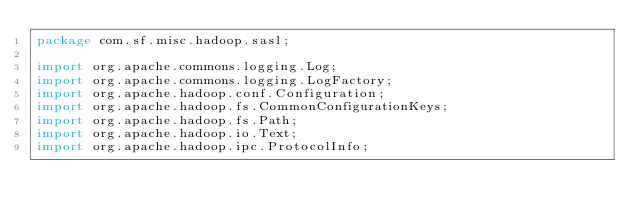<code> <loc_0><loc_0><loc_500><loc_500><_Java_>package com.sf.misc.hadoop.sasl;

import org.apache.commons.logging.Log;
import org.apache.commons.logging.LogFactory;
import org.apache.hadoop.conf.Configuration;
import org.apache.hadoop.fs.CommonConfigurationKeys;
import org.apache.hadoop.fs.Path;
import org.apache.hadoop.io.Text;
import org.apache.hadoop.ipc.ProtocolInfo;</code> 